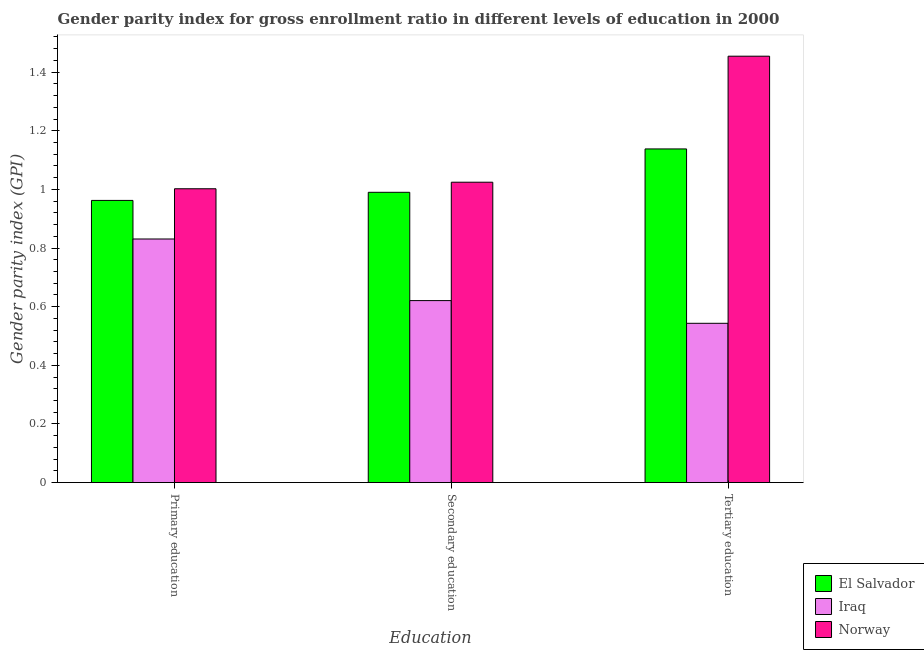How many groups of bars are there?
Keep it short and to the point. 3. Are the number of bars on each tick of the X-axis equal?
Your answer should be very brief. Yes. How many bars are there on the 3rd tick from the left?
Your answer should be very brief. 3. What is the label of the 1st group of bars from the left?
Provide a short and direct response. Primary education. What is the gender parity index in tertiary education in Iraq?
Provide a short and direct response. 0.54. Across all countries, what is the maximum gender parity index in primary education?
Provide a succinct answer. 1. Across all countries, what is the minimum gender parity index in primary education?
Give a very brief answer. 0.83. In which country was the gender parity index in primary education minimum?
Your response must be concise. Iraq. What is the total gender parity index in secondary education in the graph?
Provide a succinct answer. 2.64. What is the difference between the gender parity index in tertiary education in Iraq and that in Norway?
Make the answer very short. -0.91. What is the difference between the gender parity index in secondary education in Norway and the gender parity index in tertiary education in El Salvador?
Make the answer very short. -0.11. What is the average gender parity index in secondary education per country?
Keep it short and to the point. 0.88. What is the difference between the gender parity index in primary education and gender parity index in secondary education in Iraq?
Offer a very short reply. 0.21. In how many countries, is the gender parity index in tertiary education greater than 0.48000000000000004 ?
Keep it short and to the point. 3. What is the ratio of the gender parity index in primary education in El Salvador to that in Iraq?
Your answer should be very brief. 1.16. What is the difference between the highest and the second highest gender parity index in tertiary education?
Your answer should be compact. 0.32. What is the difference between the highest and the lowest gender parity index in tertiary education?
Your answer should be compact. 0.91. Is the sum of the gender parity index in secondary education in El Salvador and Norway greater than the maximum gender parity index in tertiary education across all countries?
Your response must be concise. Yes. What does the 1st bar from the left in Secondary education represents?
Your answer should be compact. El Salvador. What does the 2nd bar from the right in Tertiary education represents?
Make the answer very short. Iraq. Is it the case that in every country, the sum of the gender parity index in primary education and gender parity index in secondary education is greater than the gender parity index in tertiary education?
Your answer should be compact. Yes. How many bars are there?
Offer a very short reply. 9. Are all the bars in the graph horizontal?
Your answer should be compact. No. How many countries are there in the graph?
Provide a succinct answer. 3. Does the graph contain any zero values?
Make the answer very short. No. Does the graph contain grids?
Make the answer very short. No. Where does the legend appear in the graph?
Provide a succinct answer. Bottom right. How are the legend labels stacked?
Your response must be concise. Vertical. What is the title of the graph?
Provide a short and direct response. Gender parity index for gross enrollment ratio in different levels of education in 2000. What is the label or title of the X-axis?
Offer a terse response. Education. What is the label or title of the Y-axis?
Your answer should be compact. Gender parity index (GPI). What is the Gender parity index (GPI) in El Salvador in Primary education?
Offer a terse response. 0.96. What is the Gender parity index (GPI) in Iraq in Primary education?
Provide a succinct answer. 0.83. What is the Gender parity index (GPI) in Norway in Primary education?
Offer a terse response. 1. What is the Gender parity index (GPI) in El Salvador in Secondary education?
Ensure brevity in your answer.  0.99. What is the Gender parity index (GPI) of Iraq in Secondary education?
Offer a terse response. 0.62. What is the Gender parity index (GPI) in Norway in Secondary education?
Provide a succinct answer. 1.02. What is the Gender parity index (GPI) in El Salvador in Tertiary education?
Offer a very short reply. 1.14. What is the Gender parity index (GPI) of Iraq in Tertiary education?
Give a very brief answer. 0.54. What is the Gender parity index (GPI) of Norway in Tertiary education?
Give a very brief answer. 1.45. Across all Education, what is the maximum Gender parity index (GPI) in El Salvador?
Offer a terse response. 1.14. Across all Education, what is the maximum Gender parity index (GPI) of Iraq?
Give a very brief answer. 0.83. Across all Education, what is the maximum Gender parity index (GPI) in Norway?
Provide a succinct answer. 1.45. Across all Education, what is the minimum Gender parity index (GPI) of El Salvador?
Make the answer very short. 0.96. Across all Education, what is the minimum Gender parity index (GPI) of Iraq?
Ensure brevity in your answer.  0.54. Across all Education, what is the minimum Gender parity index (GPI) of Norway?
Your answer should be compact. 1. What is the total Gender parity index (GPI) of El Salvador in the graph?
Give a very brief answer. 3.09. What is the total Gender parity index (GPI) in Iraq in the graph?
Your response must be concise. 2. What is the total Gender parity index (GPI) in Norway in the graph?
Provide a succinct answer. 3.48. What is the difference between the Gender parity index (GPI) of El Salvador in Primary education and that in Secondary education?
Ensure brevity in your answer.  -0.03. What is the difference between the Gender parity index (GPI) in Iraq in Primary education and that in Secondary education?
Provide a succinct answer. 0.21. What is the difference between the Gender parity index (GPI) in Norway in Primary education and that in Secondary education?
Your response must be concise. -0.02. What is the difference between the Gender parity index (GPI) in El Salvador in Primary education and that in Tertiary education?
Provide a succinct answer. -0.18. What is the difference between the Gender parity index (GPI) in Iraq in Primary education and that in Tertiary education?
Offer a very short reply. 0.29. What is the difference between the Gender parity index (GPI) of Norway in Primary education and that in Tertiary education?
Provide a short and direct response. -0.45. What is the difference between the Gender parity index (GPI) in El Salvador in Secondary education and that in Tertiary education?
Your answer should be very brief. -0.15. What is the difference between the Gender parity index (GPI) of Iraq in Secondary education and that in Tertiary education?
Give a very brief answer. 0.08. What is the difference between the Gender parity index (GPI) in Norway in Secondary education and that in Tertiary education?
Make the answer very short. -0.43. What is the difference between the Gender parity index (GPI) of El Salvador in Primary education and the Gender parity index (GPI) of Iraq in Secondary education?
Provide a succinct answer. 0.34. What is the difference between the Gender parity index (GPI) in El Salvador in Primary education and the Gender parity index (GPI) in Norway in Secondary education?
Give a very brief answer. -0.06. What is the difference between the Gender parity index (GPI) in Iraq in Primary education and the Gender parity index (GPI) in Norway in Secondary education?
Your answer should be very brief. -0.19. What is the difference between the Gender parity index (GPI) of El Salvador in Primary education and the Gender parity index (GPI) of Iraq in Tertiary education?
Your answer should be compact. 0.42. What is the difference between the Gender parity index (GPI) of El Salvador in Primary education and the Gender parity index (GPI) of Norway in Tertiary education?
Your response must be concise. -0.49. What is the difference between the Gender parity index (GPI) in Iraq in Primary education and the Gender parity index (GPI) in Norway in Tertiary education?
Offer a very short reply. -0.62. What is the difference between the Gender parity index (GPI) of El Salvador in Secondary education and the Gender parity index (GPI) of Iraq in Tertiary education?
Provide a succinct answer. 0.45. What is the difference between the Gender parity index (GPI) in El Salvador in Secondary education and the Gender parity index (GPI) in Norway in Tertiary education?
Your response must be concise. -0.46. What is the difference between the Gender parity index (GPI) of Iraq in Secondary education and the Gender parity index (GPI) of Norway in Tertiary education?
Keep it short and to the point. -0.83. What is the average Gender parity index (GPI) of El Salvador per Education?
Offer a very short reply. 1.03. What is the average Gender parity index (GPI) in Iraq per Education?
Your answer should be compact. 0.67. What is the average Gender parity index (GPI) in Norway per Education?
Ensure brevity in your answer.  1.16. What is the difference between the Gender parity index (GPI) of El Salvador and Gender parity index (GPI) of Iraq in Primary education?
Ensure brevity in your answer.  0.13. What is the difference between the Gender parity index (GPI) in El Salvador and Gender parity index (GPI) in Norway in Primary education?
Offer a terse response. -0.04. What is the difference between the Gender parity index (GPI) in Iraq and Gender parity index (GPI) in Norway in Primary education?
Provide a succinct answer. -0.17. What is the difference between the Gender parity index (GPI) of El Salvador and Gender parity index (GPI) of Iraq in Secondary education?
Keep it short and to the point. 0.37. What is the difference between the Gender parity index (GPI) in El Salvador and Gender parity index (GPI) in Norway in Secondary education?
Your response must be concise. -0.03. What is the difference between the Gender parity index (GPI) in Iraq and Gender parity index (GPI) in Norway in Secondary education?
Make the answer very short. -0.4. What is the difference between the Gender parity index (GPI) in El Salvador and Gender parity index (GPI) in Iraq in Tertiary education?
Your answer should be compact. 0.59. What is the difference between the Gender parity index (GPI) of El Salvador and Gender parity index (GPI) of Norway in Tertiary education?
Offer a terse response. -0.32. What is the difference between the Gender parity index (GPI) in Iraq and Gender parity index (GPI) in Norway in Tertiary education?
Keep it short and to the point. -0.91. What is the ratio of the Gender parity index (GPI) of El Salvador in Primary education to that in Secondary education?
Your answer should be compact. 0.97. What is the ratio of the Gender parity index (GPI) in Iraq in Primary education to that in Secondary education?
Your response must be concise. 1.34. What is the ratio of the Gender parity index (GPI) in Norway in Primary education to that in Secondary education?
Your response must be concise. 0.98. What is the ratio of the Gender parity index (GPI) of El Salvador in Primary education to that in Tertiary education?
Your answer should be compact. 0.85. What is the ratio of the Gender parity index (GPI) in Iraq in Primary education to that in Tertiary education?
Ensure brevity in your answer.  1.53. What is the ratio of the Gender parity index (GPI) of Norway in Primary education to that in Tertiary education?
Your response must be concise. 0.69. What is the ratio of the Gender parity index (GPI) of El Salvador in Secondary education to that in Tertiary education?
Offer a very short reply. 0.87. What is the ratio of the Gender parity index (GPI) in Iraq in Secondary education to that in Tertiary education?
Provide a succinct answer. 1.14. What is the ratio of the Gender parity index (GPI) of Norway in Secondary education to that in Tertiary education?
Keep it short and to the point. 0.7. What is the difference between the highest and the second highest Gender parity index (GPI) of El Salvador?
Ensure brevity in your answer.  0.15. What is the difference between the highest and the second highest Gender parity index (GPI) in Iraq?
Provide a short and direct response. 0.21. What is the difference between the highest and the second highest Gender parity index (GPI) of Norway?
Keep it short and to the point. 0.43. What is the difference between the highest and the lowest Gender parity index (GPI) in El Salvador?
Your answer should be compact. 0.18. What is the difference between the highest and the lowest Gender parity index (GPI) of Iraq?
Provide a succinct answer. 0.29. What is the difference between the highest and the lowest Gender parity index (GPI) of Norway?
Ensure brevity in your answer.  0.45. 